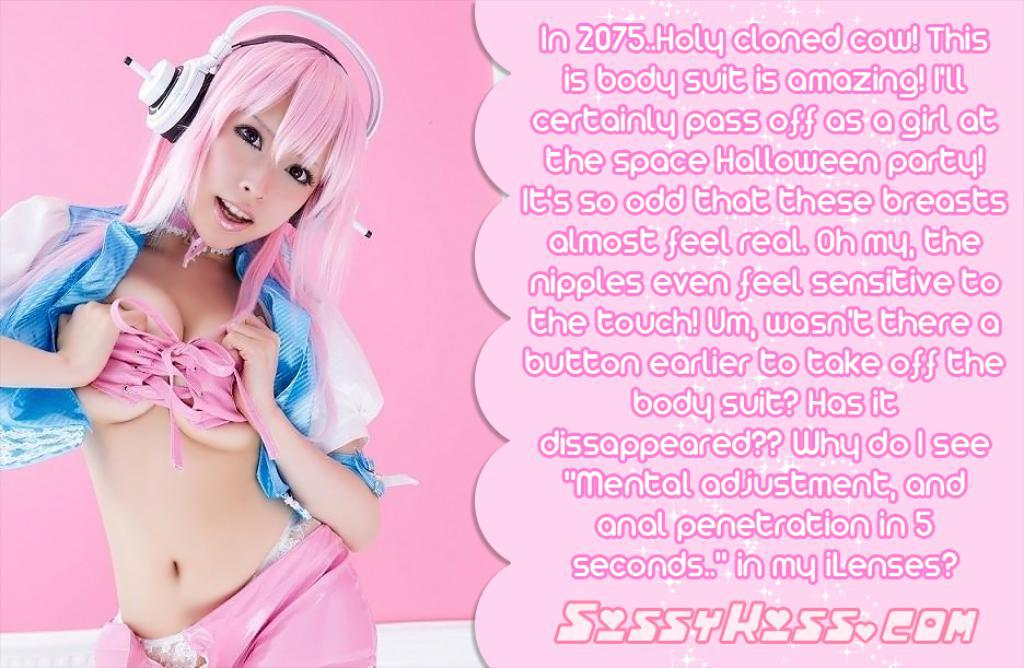Who is the main subject in the image? There is a woman in the image. What is a unique feature of the woman's appearance? The woman has pink hair. What else can be seen on the right side of the image? There is text on the right side of the image. What color is the background of the image? The background of the image is pink. What type of cover is the duck using to stay warm in the image? There is no duck present in the image, so it is not possible to determine what type of cover the duck might be using. 